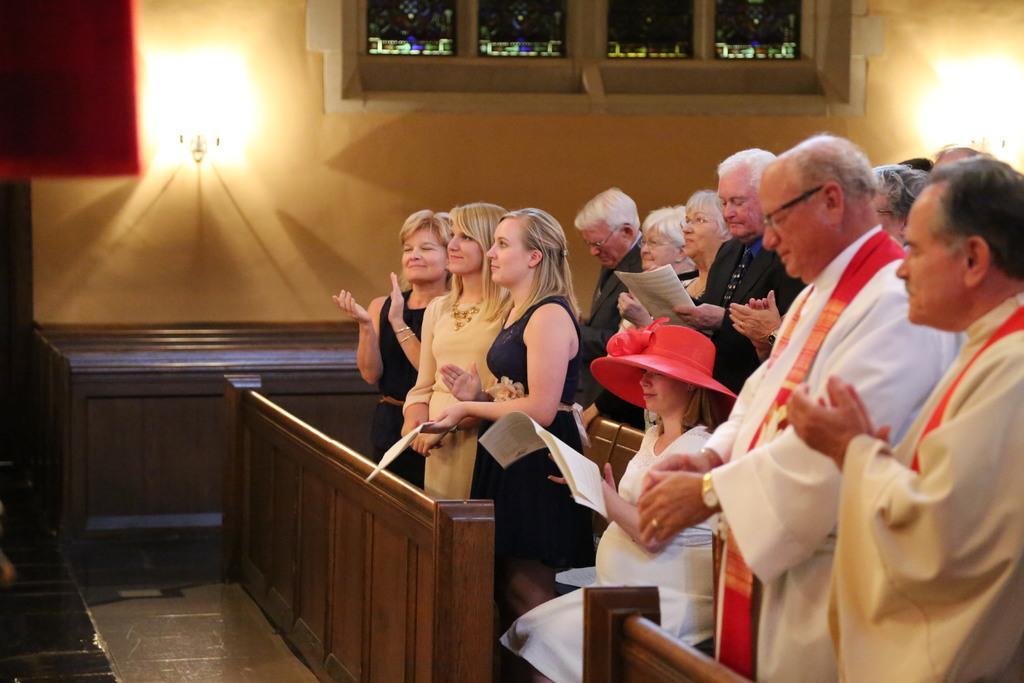Describe this image in one or two sentences. On the left side of the image there are a few people standing and few are holding papers and there is a girl sitting and holding papers in her hand, in front of them there is a wooden wall. In the background there is a lamp on the wall and windows. 